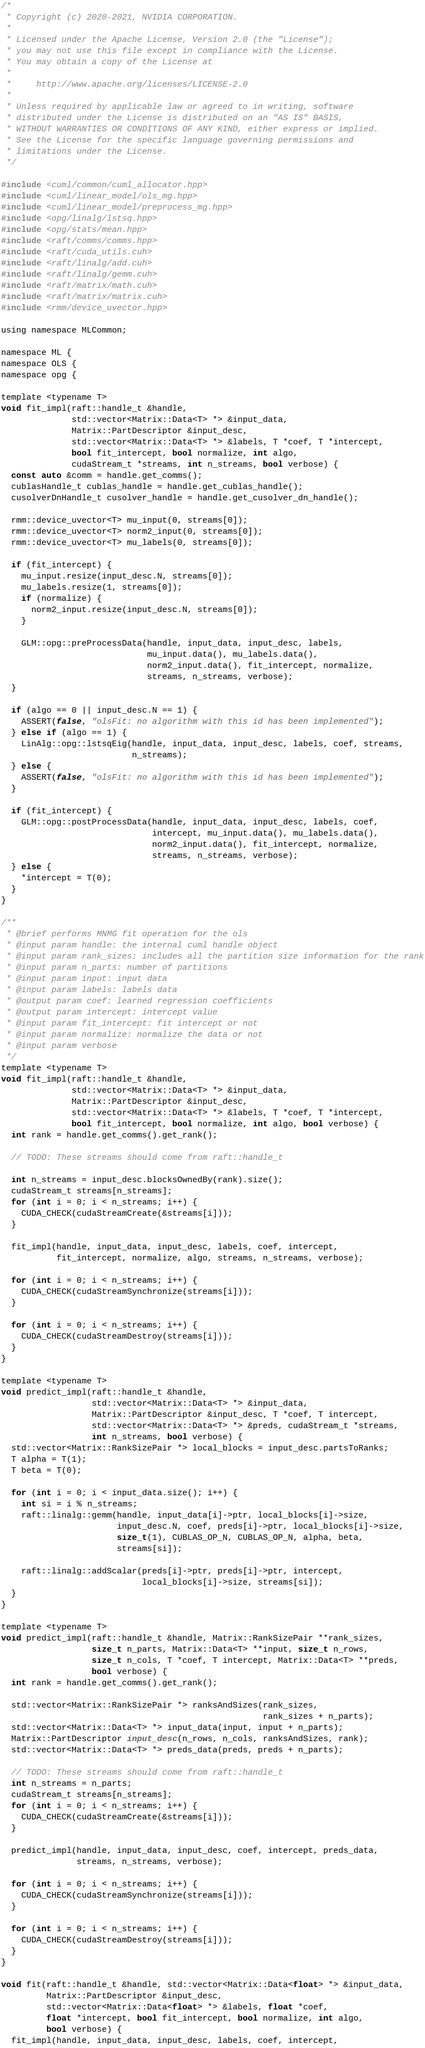<code> <loc_0><loc_0><loc_500><loc_500><_Cuda_>/*
 * Copyright (c) 2020-2021, NVIDIA CORPORATION.
 *
 * Licensed under the Apache License, Version 2.0 (the "License");
 * you may not use this file except in compliance with the License.
 * You may obtain a copy of the License at
 *
 *     http://www.apache.org/licenses/LICENSE-2.0
 *
 * Unless required by applicable law or agreed to in writing, software
 * distributed under the License is distributed on an "AS IS" BASIS,
 * WITHOUT WARRANTIES OR CONDITIONS OF ANY KIND, either express or implied.
 * See the License for the specific language governing permissions and
 * limitations under the License.
 */

#include <cuml/common/cuml_allocator.hpp>
#include <cuml/linear_model/ols_mg.hpp>
#include <cuml/linear_model/preprocess_mg.hpp>
#include <opg/linalg/lstsq.hpp>
#include <opg/stats/mean.hpp>
#include <raft/comms/comms.hpp>
#include <raft/cuda_utils.cuh>
#include <raft/linalg/add.cuh>
#include <raft/linalg/gemm.cuh>
#include <raft/matrix/math.cuh>
#include <raft/matrix/matrix.cuh>
#include <rmm/device_uvector.hpp>

using namespace MLCommon;

namespace ML {
namespace OLS {
namespace opg {

template <typename T>
void fit_impl(raft::handle_t &handle,
              std::vector<Matrix::Data<T> *> &input_data,
              Matrix::PartDescriptor &input_desc,
              std::vector<Matrix::Data<T> *> &labels, T *coef, T *intercept,
              bool fit_intercept, bool normalize, int algo,
              cudaStream_t *streams, int n_streams, bool verbose) {
  const auto &comm = handle.get_comms();
  cublasHandle_t cublas_handle = handle.get_cublas_handle();
  cusolverDnHandle_t cusolver_handle = handle.get_cusolver_dn_handle();

  rmm::device_uvector<T> mu_input(0, streams[0]);
  rmm::device_uvector<T> norm2_input(0, streams[0]);
  rmm::device_uvector<T> mu_labels(0, streams[0]);

  if (fit_intercept) {
    mu_input.resize(input_desc.N, streams[0]);
    mu_labels.resize(1, streams[0]);
    if (normalize) {
      norm2_input.resize(input_desc.N, streams[0]);
    }

    GLM::opg::preProcessData(handle, input_data, input_desc, labels,
                             mu_input.data(), mu_labels.data(),
                             norm2_input.data(), fit_intercept, normalize,
                             streams, n_streams, verbose);
  }

  if (algo == 0 || input_desc.N == 1) {
    ASSERT(false, "olsFit: no algorithm with this id has been implemented");
  } else if (algo == 1) {
    LinAlg::opg::lstsqEig(handle, input_data, input_desc, labels, coef, streams,
                          n_streams);
  } else {
    ASSERT(false, "olsFit: no algorithm with this id has been implemented");
  }

  if (fit_intercept) {
    GLM::opg::postProcessData(handle, input_data, input_desc, labels, coef,
                              intercept, mu_input.data(), mu_labels.data(),
                              norm2_input.data(), fit_intercept, normalize,
                              streams, n_streams, verbose);
  } else {
    *intercept = T(0);
  }
}

/**
 * @brief performs MNMG fit operation for the ols
 * @input param handle: the internal cuml handle object
 * @input param rank_sizes: includes all the partition size information for the rank
 * @input param n_parts: number of partitions
 * @input param input: input data
 * @input param labels: labels data
 * @output param coef: learned regression coefficients
 * @output param intercept: intercept value
 * @input param fit_intercept: fit intercept or not
 * @input param normalize: normalize the data or not
 * @input param verbose
 */
template <typename T>
void fit_impl(raft::handle_t &handle,
              std::vector<Matrix::Data<T> *> &input_data,
              Matrix::PartDescriptor &input_desc,
              std::vector<Matrix::Data<T> *> &labels, T *coef, T *intercept,
              bool fit_intercept, bool normalize, int algo, bool verbose) {
  int rank = handle.get_comms().get_rank();

  // TODO: These streams should come from raft::handle_t

  int n_streams = input_desc.blocksOwnedBy(rank).size();
  cudaStream_t streams[n_streams];
  for (int i = 0; i < n_streams; i++) {
    CUDA_CHECK(cudaStreamCreate(&streams[i]));
  }

  fit_impl(handle, input_data, input_desc, labels, coef, intercept,
           fit_intercept, normalize, algo, streams, n_streams, verbose);

  for (int i = 0; i < n_streams; i++) {
    CUDA_CHECK(cudaStreamSynchronize(streams[i]));
  }

  for (int i = 0; i < n_streams; i++) {
    CUDA_CHECK(cudaStreamDestroy(streams[i]));
  }
}

template <typename T>
void predict_impl(raft::handle_t &handle,
                  std::vector<Matrix::Data<T> *> &input_data,
                  Matrix::PartDescriptor &input_desc, T *coef, T intercept,
                  std::vector<Matrix::Data<T> *> &preds, cudaStream_t *streams,
                  int n_streams, bool verbose) {
  std::vector<Matrix::RankSizePair *> local_blocks = input_desc.partsToRanks;
  T alpha = T(1);
  T beta = T(0);

  for (int i = 0; i < input_data.size(); i++) {
    int si = i % n_streams;
    raft::linalg::gemm(handle, input_data[i]->ptr, local_blocks[i]->size,
                       input_desc.N, coef, preds[i]->ptr, local_blocks[i]->size,
                       size_t(1), CUBLAS_OP_N, CUBLAS_OP_N, alpha, beta,
                       streams[si]);

    raft::linalg::addScalar(preds[i]->ptr, preds[i]->ptr, intercept,
                            local_blocks[i]->size, streams[si]);
  }
}

template <typename T>
void predict_impl(raft::handle_t &handle, Matrix::RankSizePair **rank_sizes,
                  size_t n_parts, Matrix::Data<T> **input, size_t n_rows,
                  size_t n_cols, T *coef, T intercept, Matrix::Data<T> **preds,
                  bool verbose) {
  int rank = handle.get_comms().get_rank();

  std::vector<Matrix::RankSizePair *> ranksAndSizes(rank_sizes,
                                                    rank_sizes + n_parts);
  std::vector<Matrix::Data<T> *> input_data(input, input + n_parts);
  Matrix::PartDescriptor input_desc(n_rows, n_cols, ranksAndSizes, rank);
  std::vector<Matrix::Data<T> *> preds_data(preds, preds + n_parts);

  // TODO: These streams should come from raft::handle_t
  int n_streams = n_parts;
  cudaStream_t streams[n_streams];
  for (int i = 0; i < n_streams; i++) {
    CUDA_CHECK(cudaStreamCreate(&streams[i]));
  }

  predict_impl(handle, input_data, input_desc, coef, intercept, preds_data,
               streams, n_streams, verbose);

  for (int i = 0; i < n_streams; i++) {
    CUDA_CHECK(cudaStreamSynchronize(streams[i]));
  }

  for (int i = 0; i < n_streams; i++) {
    CUDA_CHECK(cudaStreamDestroy(streams[i]));
  }
}

void fit(raft::handle_t &handle, std::vector<Matrix::Data<float> *> &input_data,
         Matrix::PartDescriptor &input_desc,
         std::vector<Matrix::Data<float> *> &labels, float *coef,
         float *intercept, bool fit_intercept, bool normalize, int algo,
         bool verbose) {
  fit_impl(handle, input_data, input_desc, labels, coef, intercept,</code> 